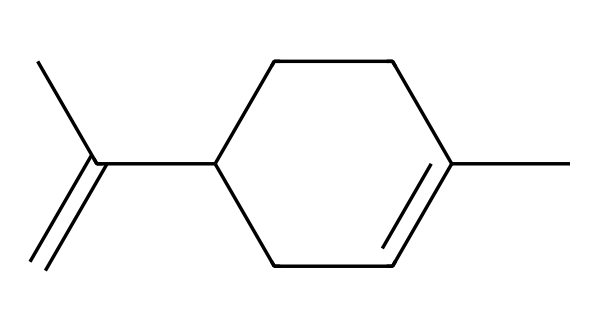What is the molecular formula of limonene? To find the molecular formula, count the number of carbon (C) and hydrogen (H) atoms in the SMILES representation. In this case, there are 10 carbon atoms and 16 hydrogen atoms. So, the molecular formula is C10H16.
Answer: C10H16 How many chiral centers are present in limonene? A chiral center is typically a carbon atom bonded to four different groups. Analyzing the structure, there are two carbon atoms that fit this criterion, indicating there are two chiral centers.
Answer: 2 What type of isomerism is exhibited by limonene? Limonene exhibits stereoisomerism due to its two chiral centers, leading to different spatial arrangements (enantiomers) of the same molecular formula, specifically D and L forms.
Answer: stereoisomerism How many rings are present in the structure of limonene? Examining the SMILES representation for rings, we can see that there is one six-membered ring in the structure of limonene.
Answer: 1 What is the significance of limonene in cleaning products? Limonene is a common ingredient in cleaning products because it has natural degreasing properties and provides a pleasant citrus scent, making it effective and appealing for use in cleaning applications.
Answer: solvent Is limonene considered an aliphatic or an aromatic compound? Limonene has a hydrocarbon structure that contains no aromatic rings; it is classified as an aliphatic compound due to its straight or branched chains, despite having a cyclic structure.
Answer: aliphatic 